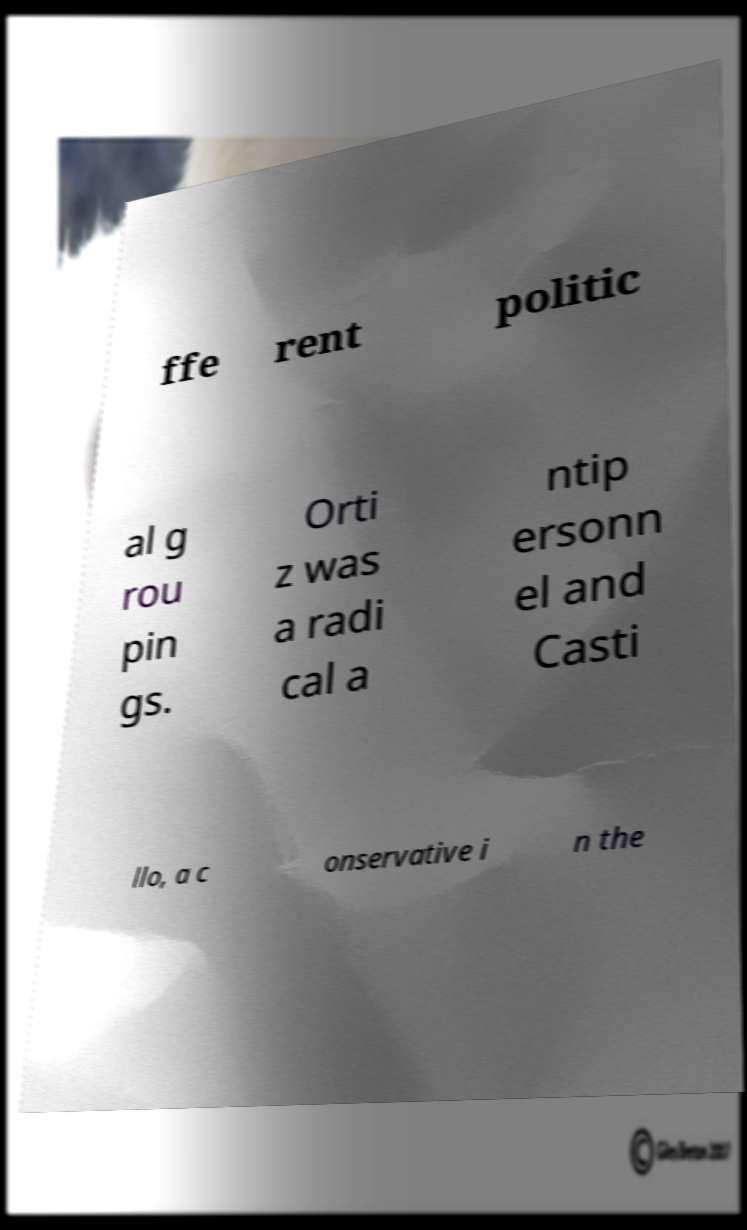Please read and relay the text visible in this image. What does it say? ffe rent politic al g rou pin gs. Orti z was a radi cal a ntip ersonn el and Casti llo, a c onservative i n the 